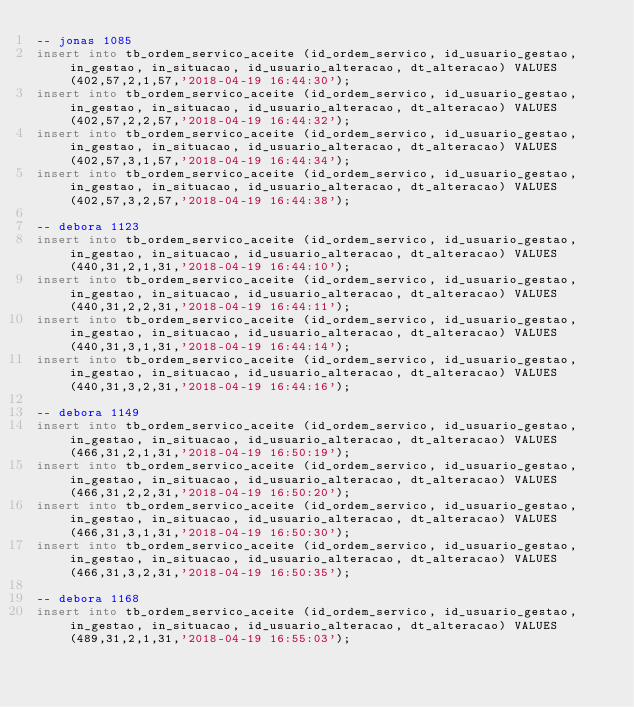<code> <loc_0><loc_0><loc_500><loc_500><_SQL_>-- jonas 1085
insert into tb_ordem_servico_aceite (id_ordem_servico, id_usuario_gestao, in_gestao, in_situacao, id_usuario_alteracao, dt_alteracao) VALUES (402,57,2,1,57,'2018-04-19 16:44:30');
insert into tb_ordem_servico_aceite (id_ordem_servico, id_usuario_gestao, in_gestao, in_situacao, id_usuario_alteracao, dt_alteracao) VALUES (402,57,2,2,57,'2018-04-19 16:44:32');
insert into tb_ordem_servico_aceite (id_ordem_servico, id_usuario_gestao, in_gestao, in_situacao, id_usuario_alteracao, dt_alteracao) VALUES (402,57,3,1,57,'2018-04-19 16:44:34');
insert into tb_ordem_servico_aceite (id_ordem_servico, id_usuario_gestao, in_gestao, in_situacao, id_usuario_alteracao, dt_alteracao) VALUES (402,57,3,2,57,'2018-04-19 16:44:38');

-- debora 1123
insert into tb_ordem_servico_aceite (id_ordem_servico, id_usuario_gestao, in_gestao, in_situacao, id_usuario_alteracao, dt_alteracao) VALUES (440,31,2,1,31,'2018-04-19 16:44:10');
insert into tb_ordem_servico_aceite (id_ordem_servico, id_usuario_gestao, in_gestao, in_situacao, id_usuario_alteracao, dt_alteracao) VALUES (440,31,2,2,31,'2018-04-19 16:44:11');
insert into tb_ordem_servico_aceite (id_ordem_servico, id_usuario_gestao, in_gestao, in_situacao, id_usuario_alteracao, dt_alteracao) VALUES (440,31,3,1,31,'2018-04-19 16:44:14');
insert into tb_ordem_servico_aceite (id_ordem_servico, id_usuario_gestao, in_gestao, in_situacao, id_usuario_alteracao, dt_alteracao) VALUES (440,31,3,2,31,'2018-04-19 16:44:16');

-- debora 1149
insert into tb_ordem_servico_aceite (id_ordem_servico, id_usuario_gestao, in_gestao, in_situacao, id_usuario_alteracao, dt_alteracao) VALUES (466,31,2,1,31,'2018-04-19 16:50:19');
insert into tb_ordem_servico_aceite (id_ordem_servico, id_usuario_gestao, in_gestao, in_situacao, id_usuario_alteracao, dt_alteracao) VALUES (466,31,2,2,31,'2018-04-19 16:50:20');
insert into tb_ordem_servico_aceite (id_ordem_servico, id_usuario_gestao, in_gestao, in_situacao, id_usuario_alteracao, dt_alteracao) VALUES (466,31,3,1,31,'2018-04-19 16:50:30');
insert into tb_ordem_servico_aceite (id_ordem_servico, id_usuario_gestao, in_gestao, in_situacao, id_usuario_alteracao, dt_alteracao) VALUES (466,31,3,2,31,'2018-04-19 16:50:35');

-- debora 1168
insert into tb_ordem_servico_aceite (id_ordem_servico, id_usuario_gestao, in_gestao, in_situacao, id_usuario_alteracao, dt_alteracao) VALUES (489,31,2,1,31,'2018-04-19 16:55:03');</code> 